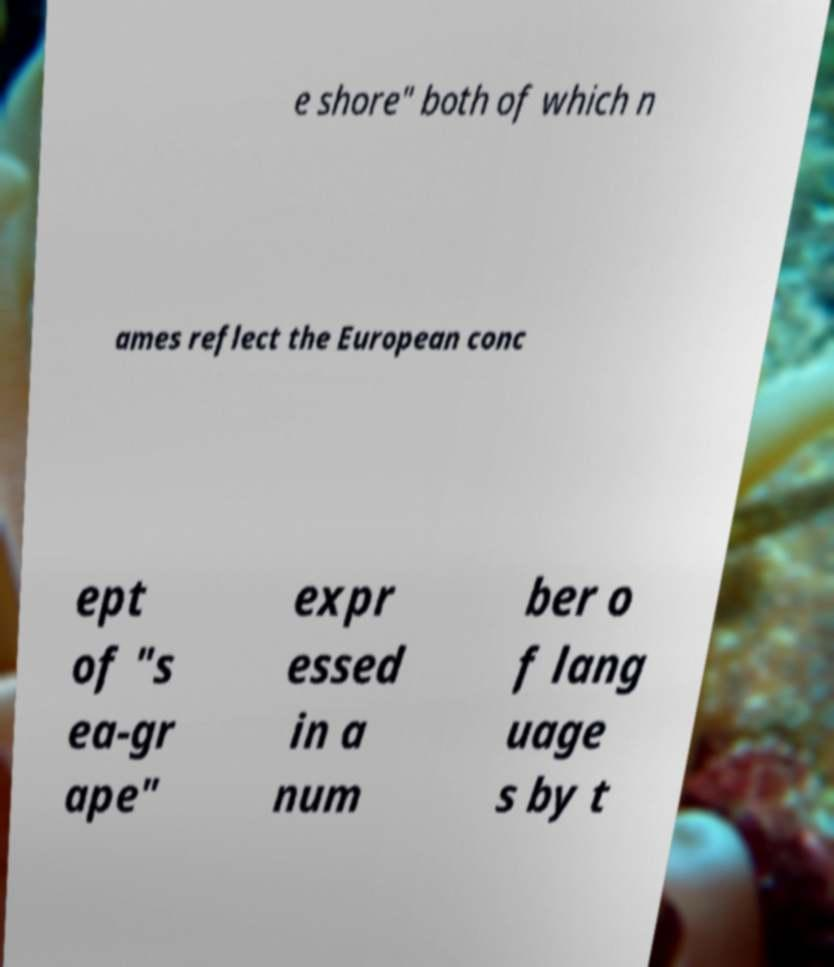Could you extract and type out the text from this image? e shore" both of which n ames reflect the European conc ept of "s ea-gr ape" expr essed in a num ber o f lang uage s by t 